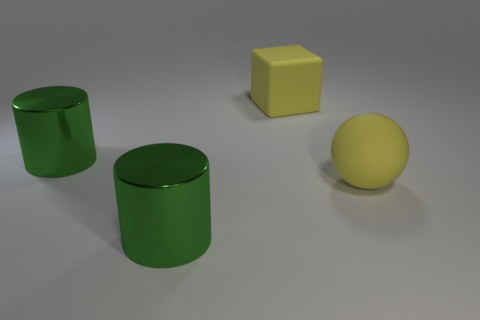The rubber sphere that is the same color as the matte cube is what size?
Your response must be concise. Large. What material is the big block that is the same color as the ball?
Offer a terse response. Rubber. Are there any yellow matte cubes to the right of the matte sphere?
Offer a terse response. No. The big object that is in front of the yellow cube and behind the rubber ball is made of what material?
Give a very brief answer. Metal. Is there a thing behind the large green shiny thing in front of the matte ball?
Ensure brevity in your answer.  Yes. The yellow block is what size?
Ensure brevity in your answer.  Large. There is a object that is both behind the yellow matte sphere and to the left of the yellow matte cube; what is its shape?
Offer a terse response. Cylinder. How many red objects are blocks or large things?
Offer a very short reply. 0. Is the size of the rubber cube that is behind the large yellow matte ball the same as the matte object that is to the right of the yellow cube?
Make the answer very short. Yes. What number of objects are big objects or large cylinders?
Offer a very short reply. 4. 